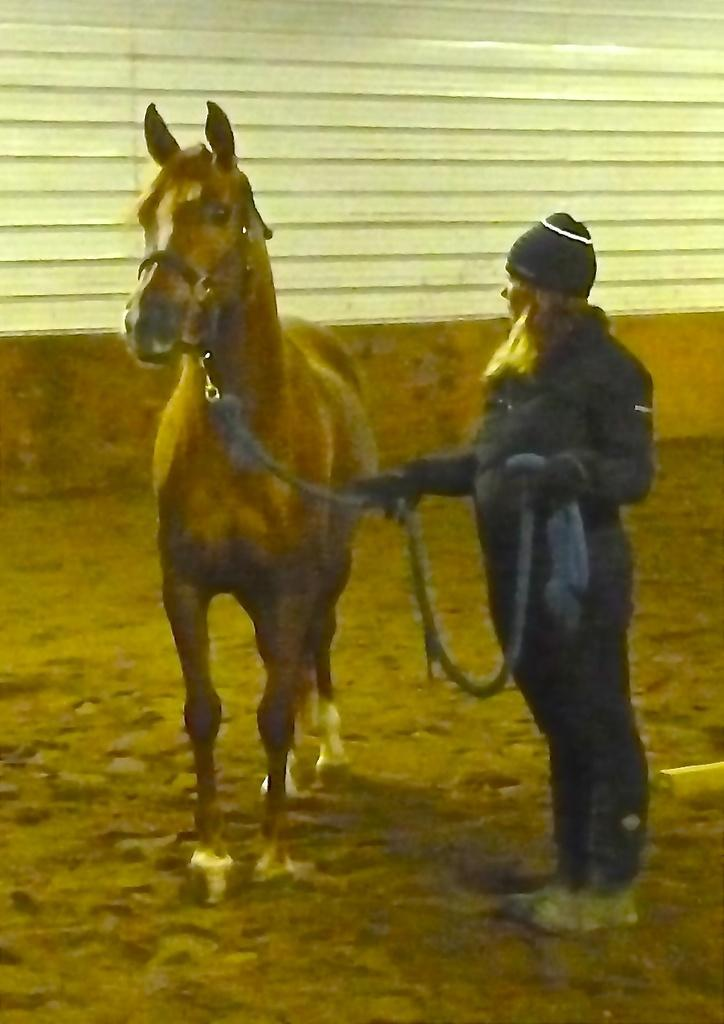Who is present in the image? There is a woman in the image. What is the woman doing in the image? The woman is standing and holding a rope. What is the rope connected to in the image? The rope is tied to a horse. Where is the horse positioned in relation to the woman? The horse is in front of the woman. What can be seen in the background of the image? There is a wall in the background of the image. What type of car can be seen in the image? There is no car present in the image. What drink is the woman holding in the image? The woman is holding a rope, not a drink, in the image. 